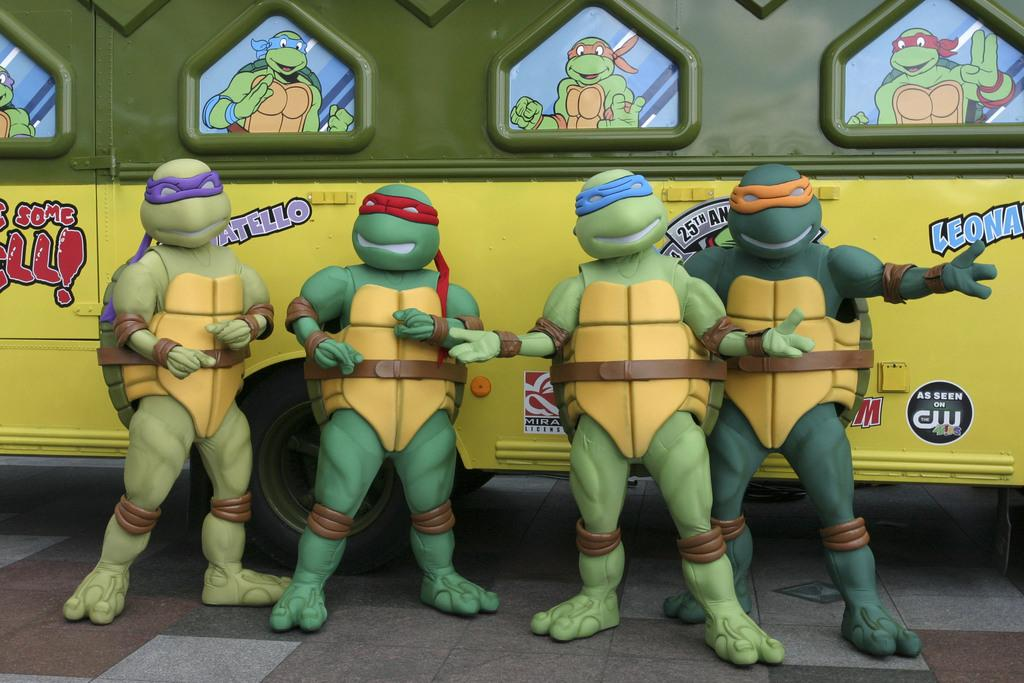What type of objects are present in the image? There are animated sculptures in the image. How are the animated sculptures positioned in the image? The animated sculptures are standing on the ground. What can be seen in the background of the image? There is a bus in the background of the image. What colors are used to depict the bus? The bus is yellow and green in color. How does the desk in the image affect the animated sculptures? There is no desk present in the image, so it cannot affect the animated sculptures. 